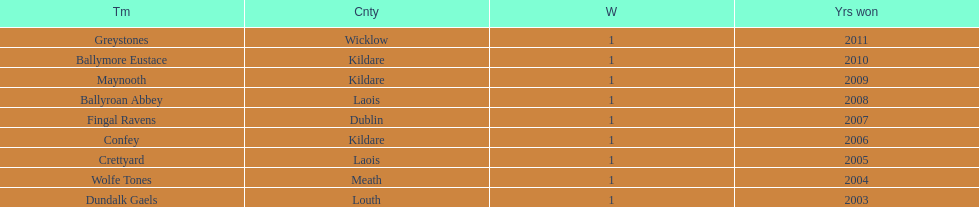What is the dissimilarity in years of victory for crettyard and greystones? 6. Would you mind parsing the complete table? {'header': ['Tm', 'Cnty', 'W', 'Yrs won'], 'rows': [['Greystones', 'Wicklow', '1', '2011'], ['Ballymore Eustace', 'Kildare', '1', '2010'], ['Maynooth', 'Kildare', '1', '2009'], ['Ballyroan Abbey', 'Laois', '1', '2008'], ['Fingal Ravens', 'Dublin', '1', '2007'], ['Confey', 'Kildare', '1', '2006'], ['Crettyard', 'Laois', '1', '2005'], ['Wolfe Tones', 'Meath', '1', '2004'], ['Dundalk Gaels', 'Louth', '1', '2003']]} 